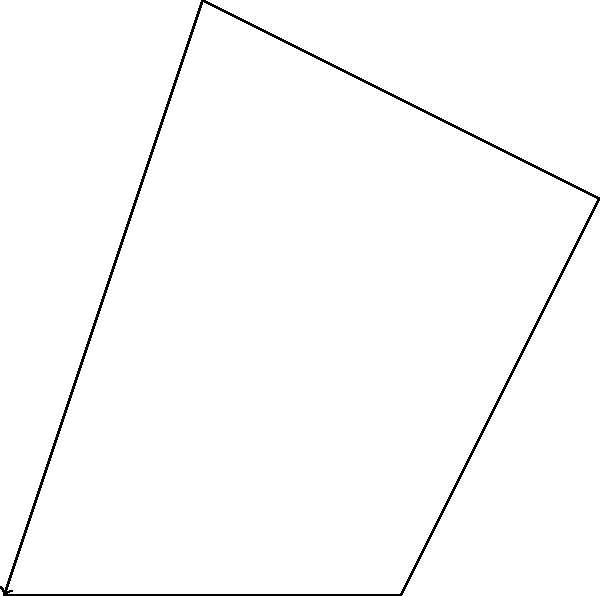In the context of WooCommerce plugin development, consider a scenario where you need to optimize the animation of a product showcase using a four-bar linkage mechanism. Given the four-bar linkage OABC shown in the figure, with link lengths $OA = 2$ units, $AB = 2$ units, $BC = 2$ units, and $OC = 3$ units, and knowing that the input link OA rotates at a constant angular velocity $\omega_2 = 10$ rad/s counterclockwise, determine the angular velocity of the output link OC ($\omega_4$) when OA is horizontal. To solve this problem, we'll use the velocity analysis method for four-bar linkages. The steps are as follows:

1) First, we need to find the transmission angle $\mu$ when OA is horizontal. We can do this using the law of cosines:

   $$\cos \mu = \frac{OA^2 + OC^2 - AC^2}{2 \cdot OA \cdot OC} = \frac{2^2 + 3^2 - 2^2}{2 \cdot 2 \cdot 3} = \frac{5}{12}$$

   $$\mu = \arccos(\frac{5}{12}) \approx 1.23 \text{ rad}$$

2) Now we can use the velocity equation for a four-bar linkage:

   $$\omega_4 = \omega_2 \cdot \frac{OA}{OC} \cdot \frac{\sin(\pi - \mu)}{\sin \mu}$$

3) Substituting the known values:

   $$\omega_4 = 10 \cdot \frac{2}{3} \cdot \frac{\sin(\pi - 1.23)}{\sin 1.23}$$

4) Simplifying:

   $$\omega_4 = 10 \cdot \frac{2}{3} \cdot \frac{\sin(1.91)}{\sin 1.23} \approx 6.67 \text{ rad/s}$$

The negative sign indicates that the output link OC rotates clockwise when the input link OA rotates counterclockwise.
Answer: $\omega_4 \approx -6.67 \text{ rad/s}$ 